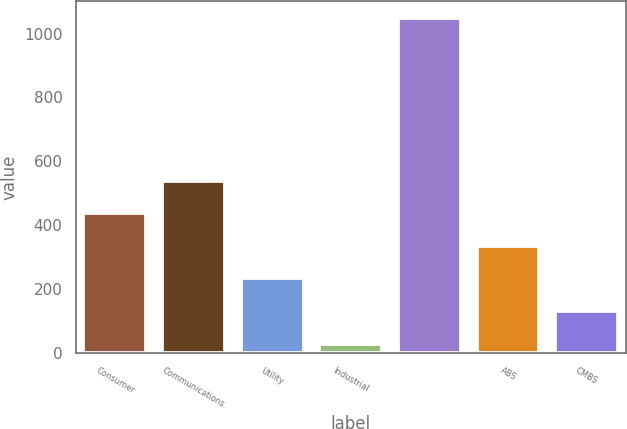Convert chart to OTSL. <chart><loc_0><loc_0><loc_500><loc_500><bar_chart><fcel>Consumer<fcel>Communications<fcel>Utility<fcel>Industrial<fcel>Unnamed: 4<fcel>ABS<fcel>CMBS<nl><fcel>438<fcel>540<fcel>234<fcel>30<fcel>1050<fcel>336<fcel>132<nl></chart> 